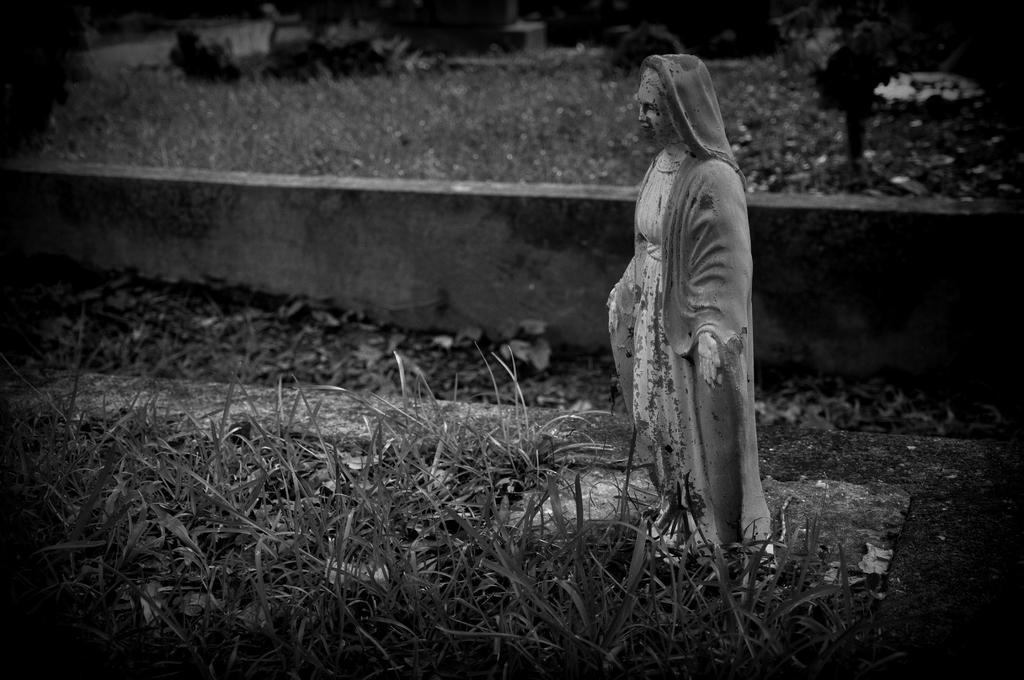Can you describe this image briefly? In this image we can see a statue, wall and grass. 